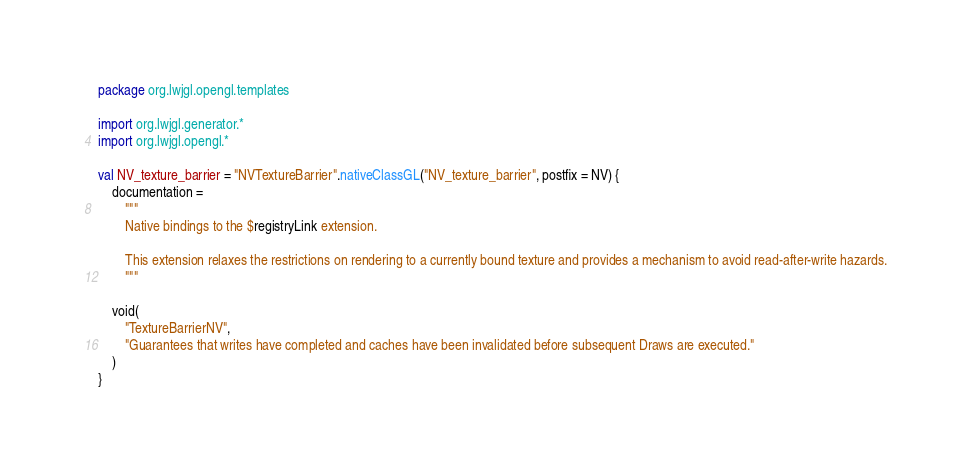Convert code to text. <code><loc_0><loc_0><loc_500><loc_500><_Kotlin_>package org.lwjgl.opengl.templates

import org.lwjgl.generator.*
import org.lwjgl.opengl.*

val NV_texture_barrier = "NVTextureBarrier".nativeClassGL("NV_texture_barrier", postfix = NV) {
    documentation =
        """
        Native bindings to the $registryLink extension.

        This extension relaxes the restrictions on rendering to a currently bound texture and provides a mechanism to avoid read-after-write hazards.
        """

    void(
        "TextureBarrierNV",
        "Guarantees that writes have completed and caches have been invalidated before subsequent Draws are executed."
    )
}</code> 